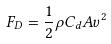Convert formula to latex. <formula><loc_0><loc_0><loc_500><loc_500>F _ { D } = \frac { 1 } { 2 } \rho C _ { d } A v ^ { 2 }</formula> 